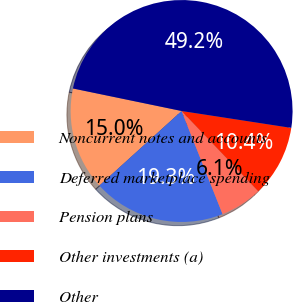Convert chart. <chart><loc_0><loc_0><loc_500><loc_500><pie_chart><fcel>Noncurrent notes and accounts<fcel>Deferred marketplace spending<fcel>Pension plans<fcel>Other investments (a)<fcel>Other<nl><fcel>14.98%<fcel>19.29%<fcel>6.12%<fcel>10.43%<fcel>49.18%<nl></chart> 